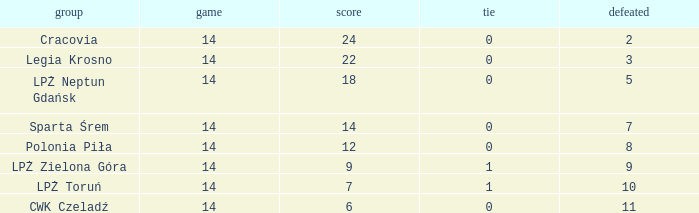What is the lowest points for a match before 14? None. 